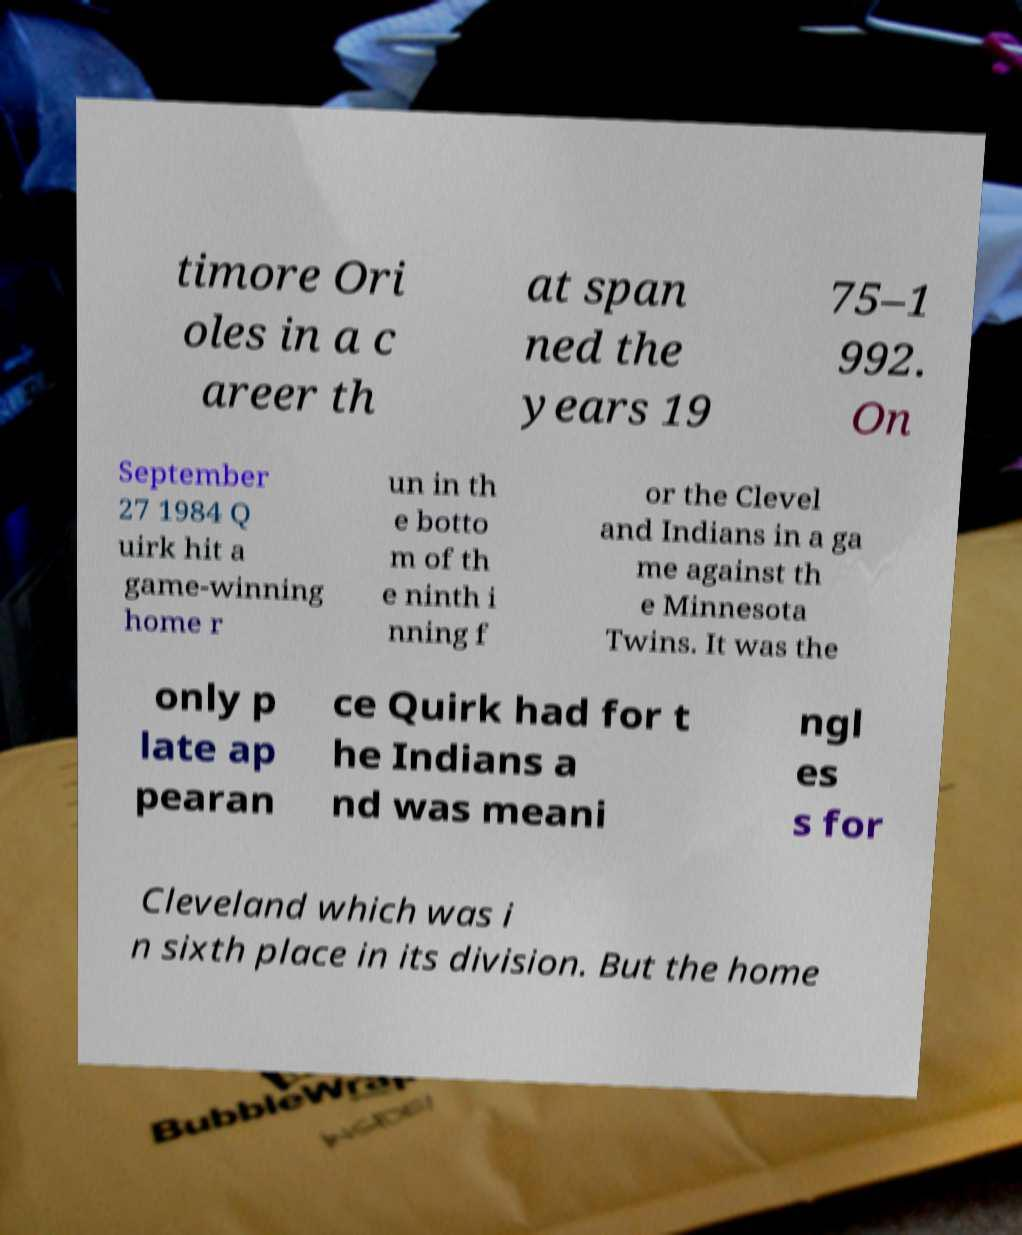Can you read and provide the text displayed in the image?This photo seems to have some interesting text. Can you extract and type it out for me? timore Ori oles in a c areer th at span ned the years 19 75–1 992. On September 27 1984 Q uirk hit a game-winning home r un in th e botto m of th e ninth i nning f or the Clevel and Indians in a ga me against th e Minnesota Twins. It was the only p late ap pearan ce Quirk had for t he Indians a nd was meani ngl es s for Cleveland which was i n sixth place in its division. But the home 